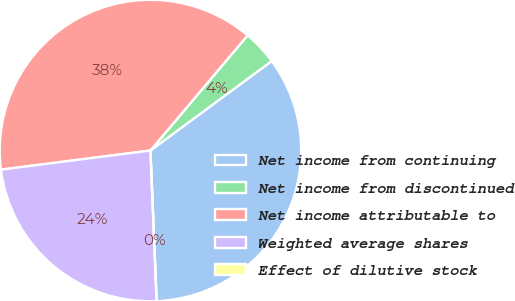<chart> <loc_0><loc_0><loc_500><loc_500><pie_chart><fcel>Net income from continuing<fcel>Net income from discontinued<fcel>Net income attributable to<fcel>Weighted average shares<fcel>Effect of dilutive stock<nl><fcel>34.46%<fcel>3.73%<fcel>38.18%<fcel>23.63%<fcel>0.0%<nl></chart> 